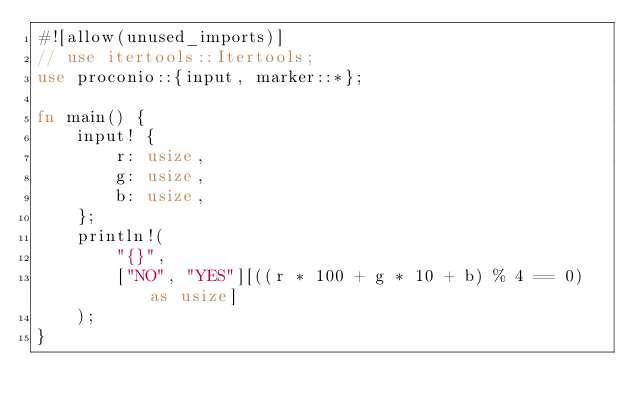Convert code to text. <code><loc_0><loc_0><loc_500><loc_500><_Rust_>#![allow(unused_imports)]
// use itertools::Itertools;
use proconio::{input, marker::*};

fn main() {
    input! {
        r: usize,
        g: usize,
        b: usize,
    };
    println!(
        "{}",
        ["NO", "YES"][((r * 100 + g * 10 + b) % 4 == 0) as usize]
    );
}
</code> 